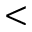Convert formula to latex. <formula><loc_0><loc_0><loc_500><loc_500><</formula> 